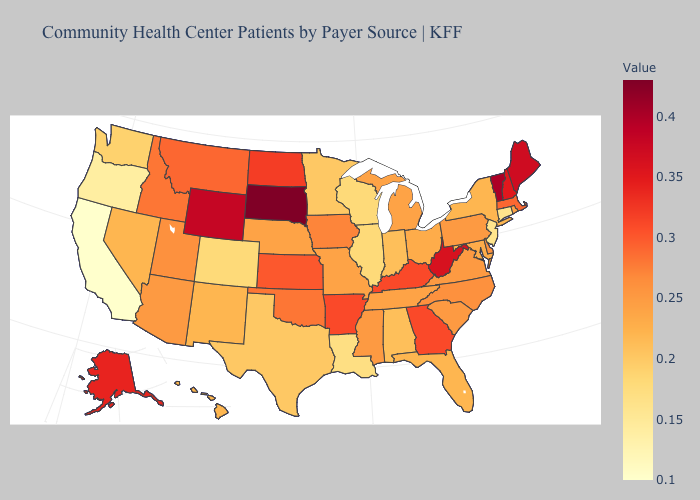Among the states that border Connecticut , does Massachusetts have the highest value?
Short answer required. Yes. Does Nevada have the highest value in the USA?
Concise answer only. No. Does Hawaii have the lowest value in the West?
Keep it brief. No. Does Wisconsin have a lower value than Oregon?
Short answer required. No. Does California have the lowest value in the USA?
Short answer required. Yes. Which states have the lowest value in the USA?
Quick response, please. California. Among the states that border Michigan , does Indiana have the highest value?
Give a very brief answer. No. 